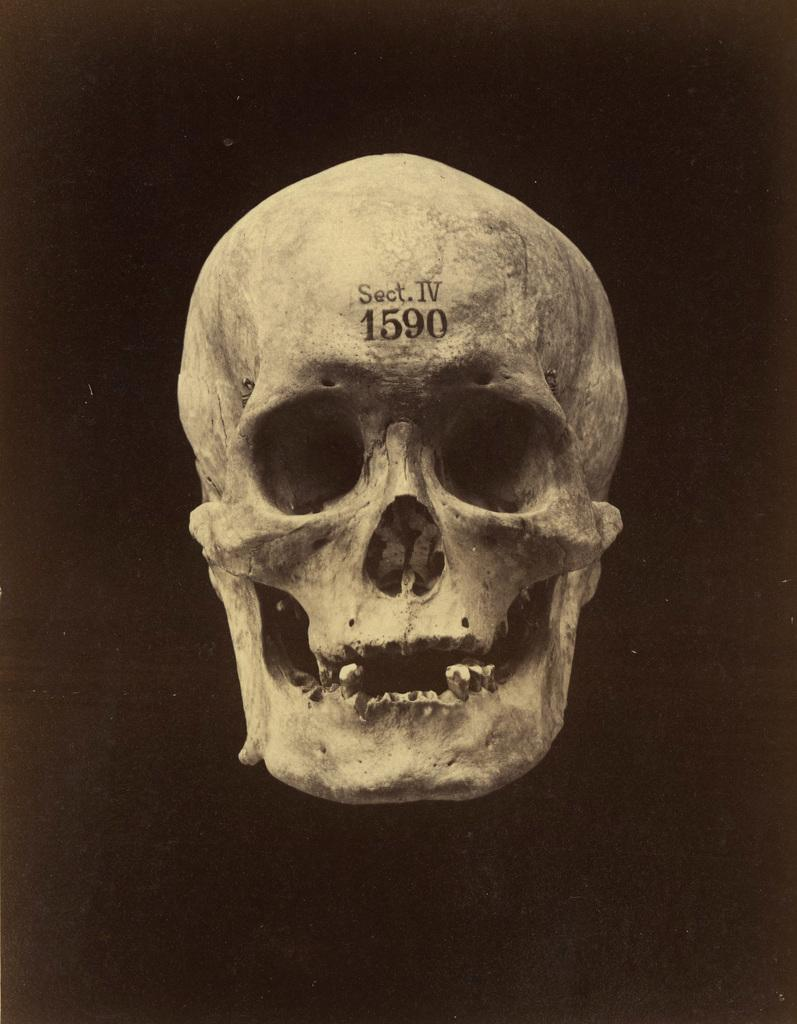What is the main subject of the image? The main subject of the image is a skull. What is written on the skull? There is text on the skull. Are there any numbers on the skull? Yes, there are numbers on the skull. What is the color of the background in the image? The background of the image is dark. How many questions are stitched onto the skull in the image? There is no mention of questions or stitching in the image; it only features a skull with text and numbers. 